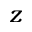Convert formula to latex. <formula><loc_0><loc_0><loc_500><loc_500>z</formula> 